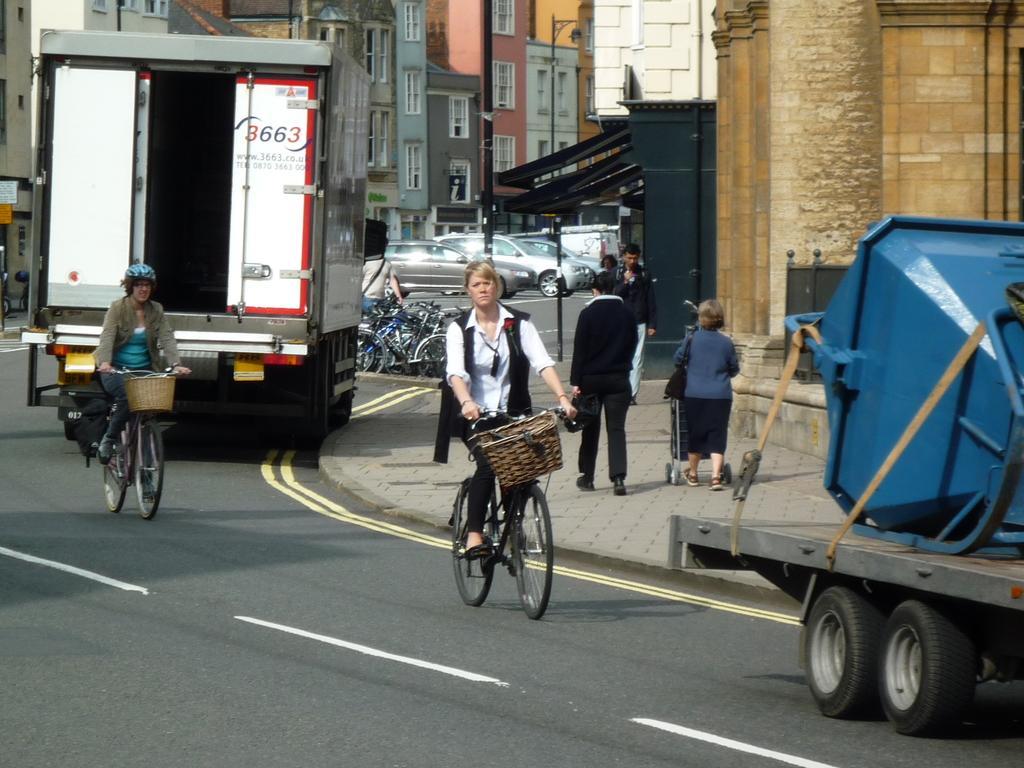Please provide a concise description of this image. The two persons are riding a bicycle on a road. In the left side we have a woman. She is wearing a helmet. In the right side we have a four persons. They are walking like slowly. In the background we can see there is a building,sky,vehicles. 